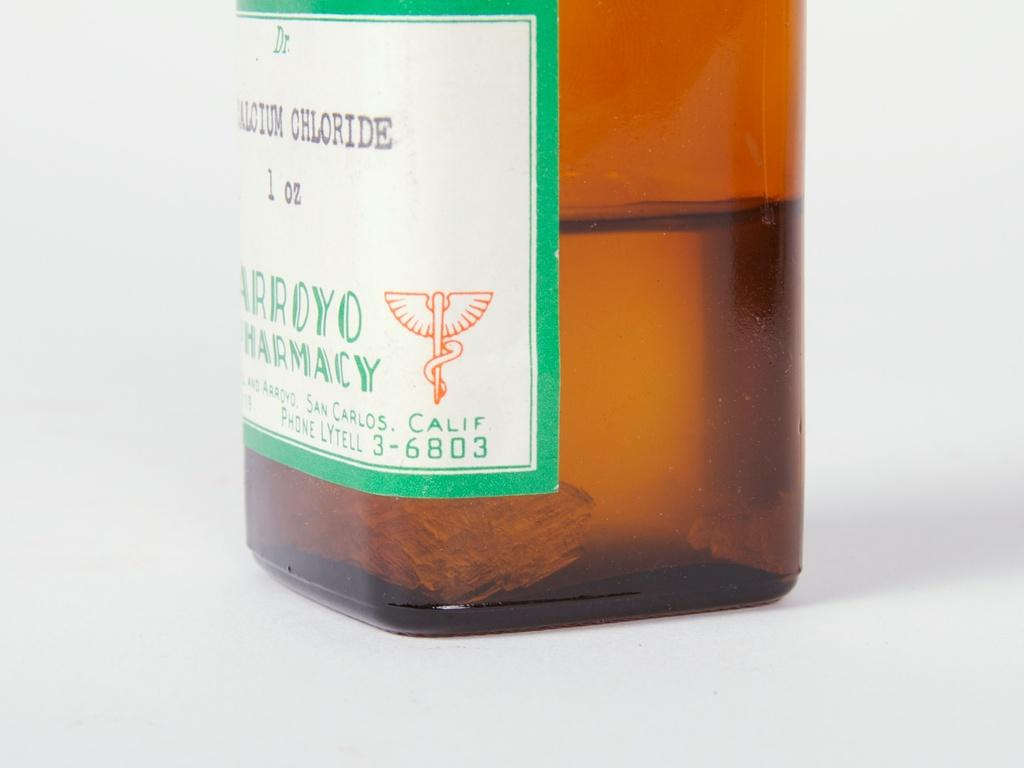<image>
Create a compact narrative representing the image presented. The bottom half of a bottle is labeled sodium chloride. 